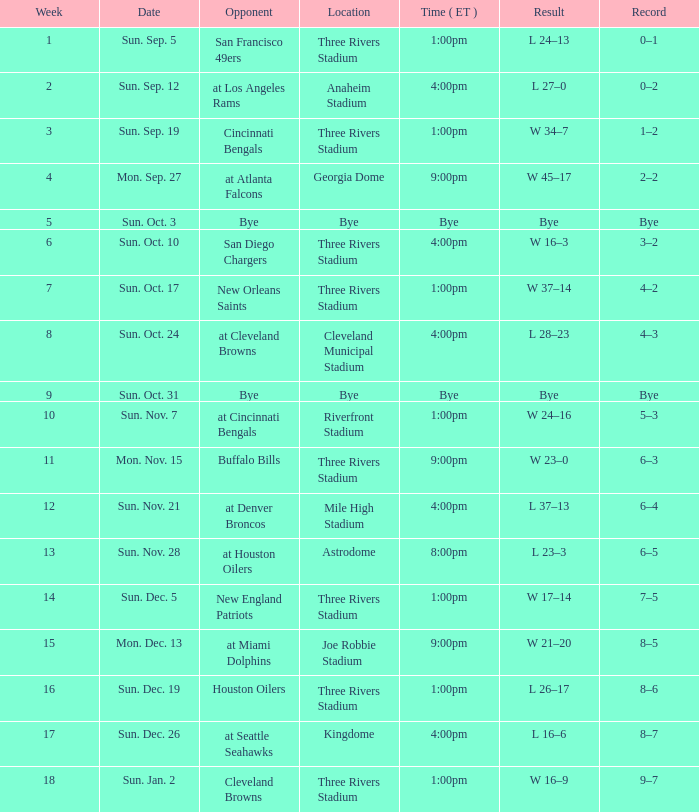What is the outcome of the game at three rivers stadium with a 6–3 record? W 23–0. 